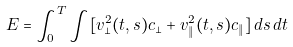Convert formula to latex. <formula><loc_0><loc_0><loc_500><loc_500>E = \int _ { 0 } ^ { T } \int [ v _ { \perp } ^ { 2 } ( t , s ) c _ { \perp } + v _ { \| } ^ { 2 } ( t , s ) c _ { \| } ] \, d s \, d t</formula> 